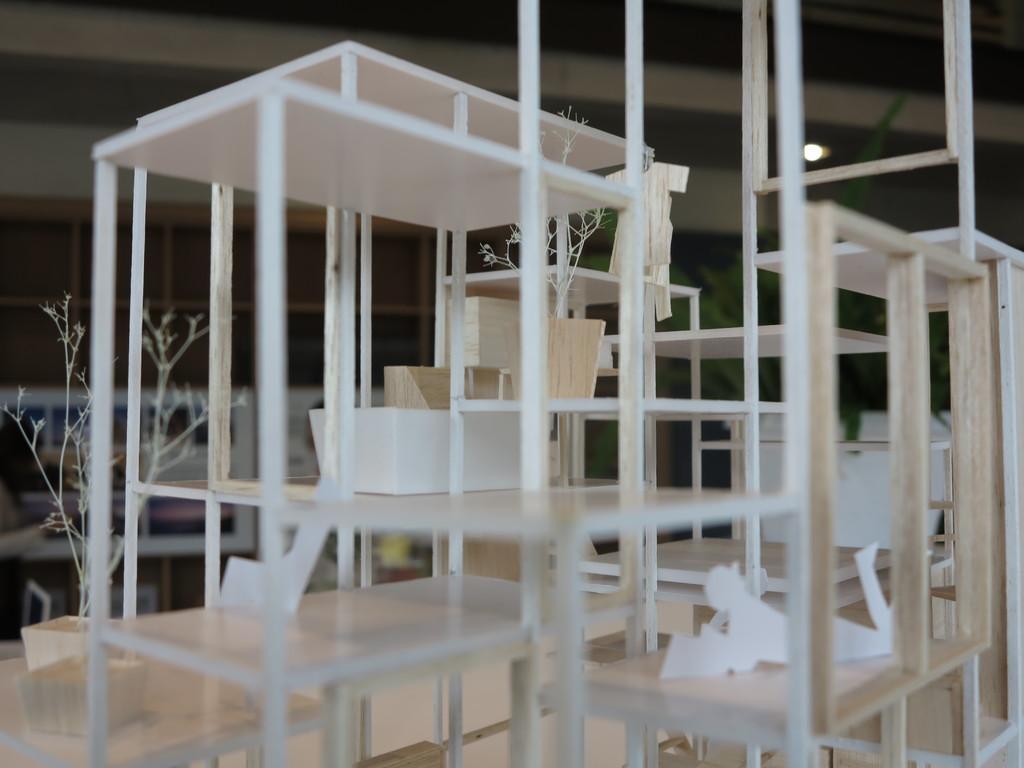Describe this image in one or two sentences. This image is clicked inside. There are pots in the middle. There are plants in that pot. There are tables in the middle. 